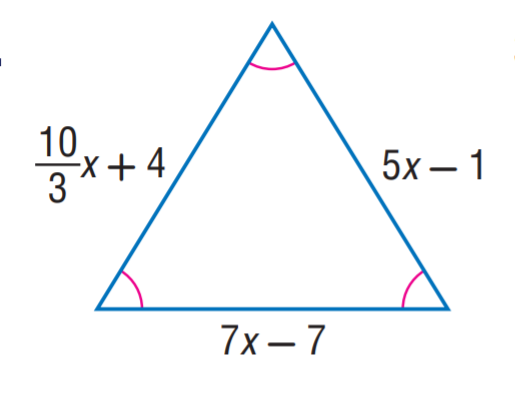Question: Find x.
Choices:
A. 1
B. 3
C. 5
D. 7
Answer with the letter. Answer: B 